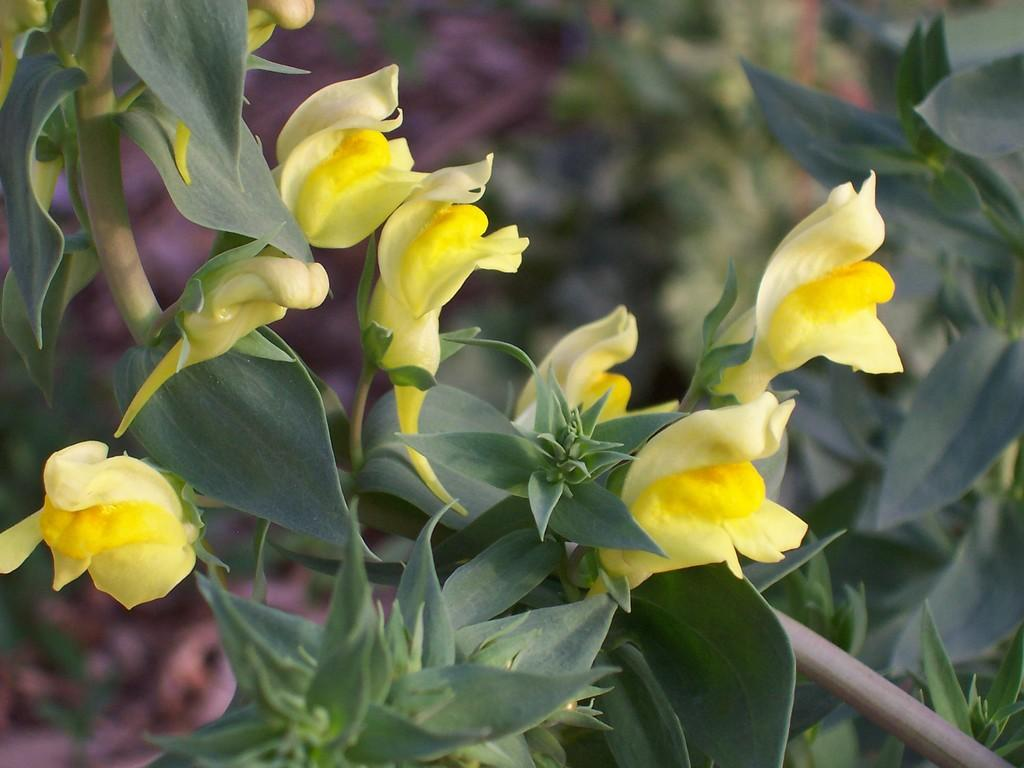What type of flowers are present in the image? There are yellow flowers in the image. What color are the leaves associated with the flowers? There are green leaves in the image. Can you describe the background of the image? The background of the image is blurry. What type of wool is being used to act as a gate in the image? There is no wool, act, or gate present in the image. 